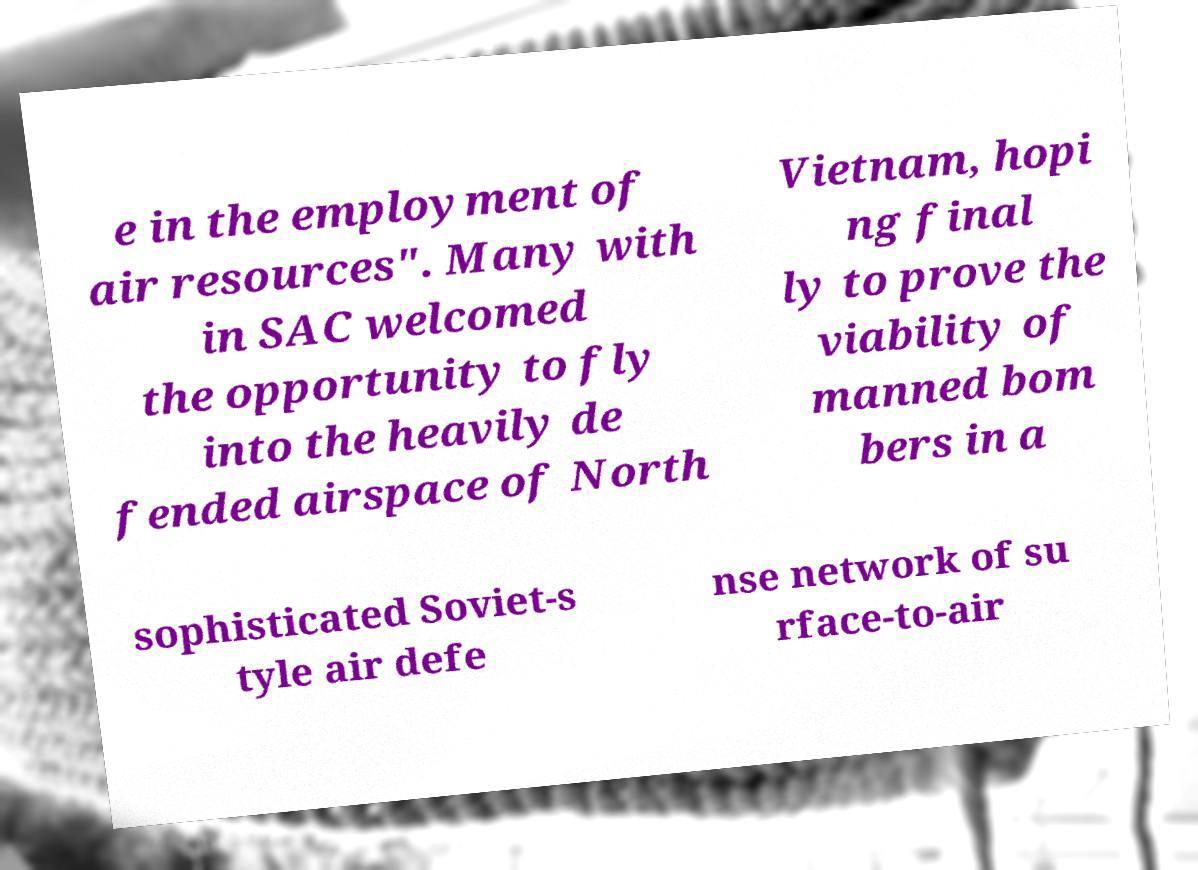Can you read and provide the text displayed in the image?This photo seems to have some interesting text. Can you extract and type it out for me? e in the employment of air resources". Many with in SAC welcomed the opportunity to fly into the heavily de fended airspace of North Vietnam, hopi ng final ly to prove the viability of manned bom bers in a sophisticated Soviet-s tyle air defe nse network of su rface-to-air 